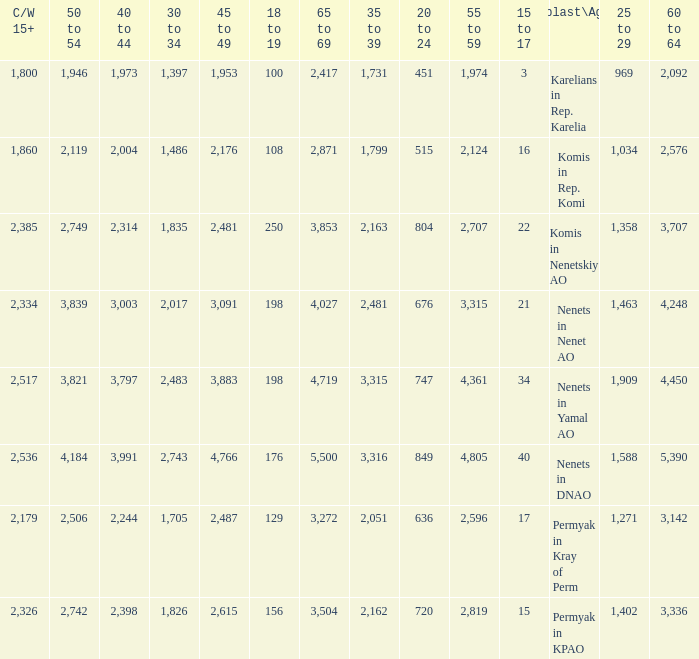What is the number of 40 to 44 when the 50 to 54 is less than 4,184, and the 15 to 17 is less than 3? 0.0. 